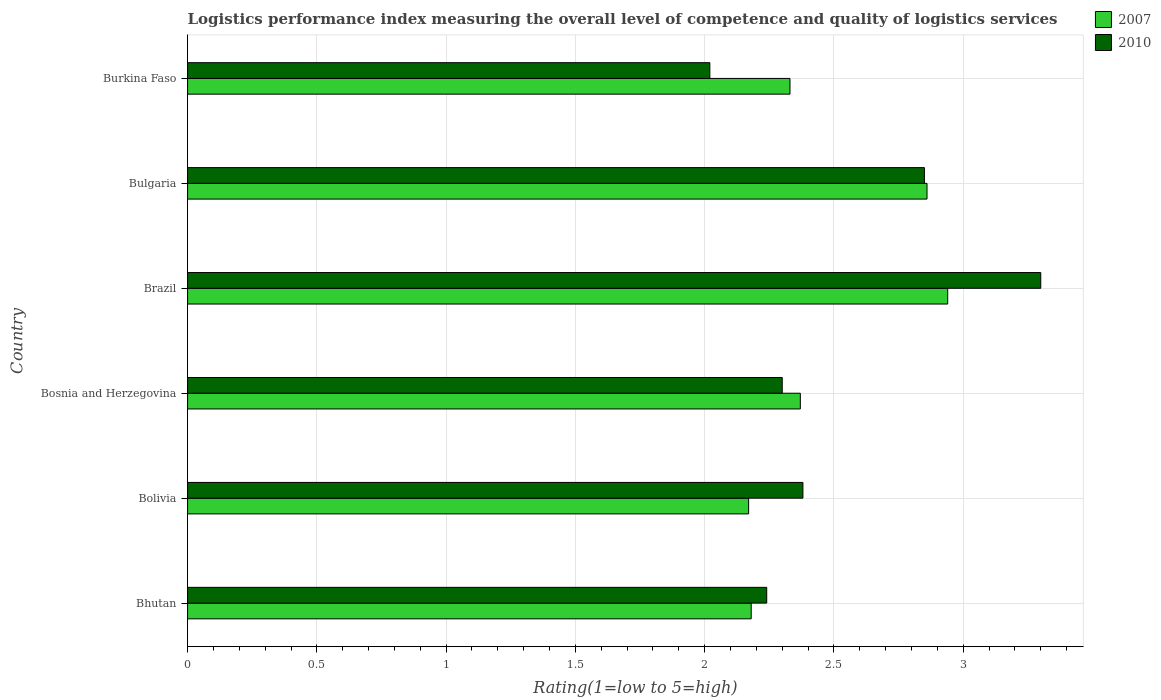How many different coloured bars are there?
Offer a very short reply. 2. Are the number of bars per tick equal to the number of legend labels?
Ensure brevity in your answer.  Yes. Are the number of bars on each tick of the Y-axis equal?
Provide a short and direct response. Yes. What is the Logistic performance index in 2010 in Bhutan?
Keep it short and to the point. 2.24. Across all countries, what is the maximum Logistic performance index in 2010?
Your answer should be very brief. 3.3. Across all countries, what is the minimum Logistic performance index in 2010?
Your answer should be compact. 2.02. In which country was the Logistic performance index in 2010 maximum?
Give a very brief answer. Brazil. In which country was the Logistic performance index in 2007 minimum?
Offer a terse response. Bolivia. What is the total Logistic performance index in 2007 in the graph?
Offer a very short reply. 14.85. What is the difference between the Logistic performance index in 2007 in Bulgaria and that in Burkina Faso?
Offer a terse response. 0.53. What is the difference between the Logistic performance index in 2007 in Bolivia and the Logistic performance index in 2010 in Bosnia and Herzegovina?
Give a very brief answer. -0.13. What is the average Logistic performance index in 2007 per country?
Your response must be concise. 2.48. What is the difference between the Logistic performance index in 2010 and Logistic performance index in 2007 in Bolivia?
Your response must be concise. 0.21. In how many countries, is the Logistic performance index in 2007 greater than 0.6 ?
Make the answer very short. 6. What is the ratio of the Logistic performance index in 2010 in Brazil to that in Bulgaria?
Offer a very short reply. 1.16. What is the difference between the highest and the second highest Logistic performance index in 2007?
Your answer should be compact. 0.08. What is the difference between the highest and the lowest Logistic performance index in 2010?
Provide a short and direct response. 1.28. What does the 2nd bar from the top in Bolivia represents?
Your response must be concise. 2007. How many bars are there?
Your response must be concise. 12. Are all the bars in the graph horizontal?
Keep it short and to the point. Yes. What is the difference between two consecutive major ticks on the X-axis?
Your answer should be very brief. 0.5. What is the title of the graph?
Your answer should be very brief. Logistics performance index measuring the overall level of competence and quality of logistics services. Does "2002" appear as one of the legend labels in the graph?
Provide a succinct answer. No. What is the label or title of the X-axis?
Give a very brief answer. Rating(1=low to 5=high). What is the Rating(1=low to 5=high) in 2007 in Bhutan?
Your answer should be compact. 2.18. What is the Rating(1=low to 5=high) in 2010 in Bhutan?
Offer a very short reply. 2.24. What is the Rating(1=low to 5=high) in 2007 in Bolivia?
Offer a terse response. 2.17. What is the Rating(1=low to 5=high) in 2010 in Bolivia?
Provide a short and direct response. 2.38. What is the Rating(1=low to 5=high) in 2007 in Bosnia and Herzegovina?
Your response must be concise. 2.37. What is the Rating(1=low to 5=high) in 2010 in Bosnia and Herzegovina?
Your answer should be very brief. 2.3. What is the Rating(1=low to 5=high) in 2007 in Brazil?
Give a very brief answer. 2.94. What is the Rating(1=low to 5=high) of 2007 in Bulgaria?
Your answer should be very brief. 2.86. What is the Rating(1=low to 5=high) in 2010 in Bulgaria?
Your answer should be very brief. 2.85. What is the Rating(1=low to 5=high) in 2007 in Burkina Faso?
Make the answer very short. 2.33. What is the Rating(1=low to 5=high) of 2010 in Burkina Faso?
Offer a terse response. 2.02. Across all countries, what is the maximum Rating(1=low to 5=high) of 2007?
Provide a succinct answer. 2.94. Across all countries, what is the maximum Rating(1=low to 5=high) in 2010?
Offer a very short reply. 3.3. Across all countries, what is the minimum Rating(1=low to 5=high) of 2007?
Provide a succinct answer. 2.17. Across all countries, what is the minimum Rating(1=low to 5=high) of 2010?
Offer a very short reply. 2.02. What is the total Rating(1=low to 5=high) of 2007 in the graph?
Keep it short and to the point. 14.85. What is the total Rating(1=low to 5=high) of 2010 in the graph?
Make the answer very short. 15.09. What is the difference between the Rating(1=low to 5=high) in 2010 in Bhutan and that in Bolivia?
Your answer should be very brief. -0.14. What is the difference between the Rating(1=low to 5=high) of 2007 in Bhutan and that in Bosnia and Herzegovina?
Provide a short and direct response. -0.19. What is the difference between the Rating(1=low to 5=high) of 2010 in Bhutan and that in Bosnia and Herzegovina?
Provide a short and direct response. -0.06. What is the difference between the Rating(1=low to 5=high) in 2007 in Bhutan and that in Brazil?
Provide a succinct answer. -0.76. What is the difference between the Rating(1=low to 5=high) of 2010 in Bhutan and that in Brazil?
Your answer should be compact. -1.06. What is the difference between the Rating(1=low to 5=high) in 2007 in Bhutan and that in Bulgaria?
Your answer should be compact. -0.68. What is the difference between the Rating(1=low to 5=high) of 2010 in Bhutan and that in Bulgaria?
Give a very brief answer. -0.61. What is the difference between the Rating(1=low to 5=high) of 2010 in Bhutan and that in Burkina Faso?
Provide a short and direct response. 0.22. What is the difference between the Rating(1=low to 5=high) in 2010 in Bolivia and that in Bosnia and Herzegovina?
Provide a succinct answer. 0.08. What is the difference between the Rating(1=low to 5=high) in 2007 in Bolivia and that in Brazil?
Keep it short and to the point. -0.77. What is the difference between the Rating(1=low to 5=high) in 2010 in Bolivia and that in Brazil?
Provide a succinct answer. -0.92. What is the difference between the Rating(1=low to 5=high) in 2007 in Bolivia and that in Bulgaria?
Provide a short and direct response. -0.69. What is the difference between the Rating(1=low to 5=high) of 2010 in Bolivia and that in Bulgaria?
Give a very brief answer. -0.47. What is the difference between the Rating(1=low to 5=high) of 2007 in Bolivia and that in Burkina Faso?
Make the answer very short. -0.16. What is the difference between the Rating(1=low to 5=high) in 2010 in Bolivia and that in Burkina Faso?
Your answer should be compact. 0.36. What is the difference between the Rating(1=low to 5=high) in 2007 in Bosnia and Herzegovina and that in Brazil?
Your answer should be compact. -0.57. What is the difference between the Rating(1=low to 5=high) in 2007 in Bosnia and Herzegovina and that in Bulgaria?
Make the answer very short. -0.49. What is the difference between the Rating(1=low to 5=high) of 2010 in Bosnia and Herzegovina and that in Bulgaria?
Ensure brevity in your answer.  -0.55. What is the difference between the Rating(1=low to 5=high) of 2010 in Bosnia and Herzegovina and that in Burkina Faso?
Make the answer very short. 0.28. What is the difference between the Rating(1=low to 5=high) of 2010 in Brazil and that in Bulgaria?
Offer a very short reply. 0.45. What is the difference between the Rating(1=low to 5=high) in 2007 in Brazil and that in Burkina Faso?
Keep it short and to the point. 0.61. What is the difference between the Rating(1=low to 5=high) in 2010 in Brazil and that in Burkina Faso?
Your response must be concise. 1.28. What is the difference between the Rating(1=low to 5=high) of 2007 in Bulgaria and that in Burkina Faso?
Provide a succinct answer. 0.53. What is the difference between the Rating(1=low to 5=high) of 2010 in Bulgaria and that in Burkina Faso?
Give a very brief answer. 0.83. What is the difference between the Rating(1=low to 5=high) of 2007 in Bhutan and the Rating(1=low to 5=high) of 2010 in Bosnia and Herzegovina?
Give a very brief answer. -0.12. What is the difference between the Rating(1=low to 5=high) of 2007 in Bhutan and the Rating(1=low to 5=high) of 2010 in Brazil?
Keep it short and to the point. -1.12. What is the difference between the Rating(1=low to 5=high) in 2007 in Bhutan and the Rating(1=low to 5=high) in 2010 in Bulgaria?
Make the answer very short. -0.67. What is the difference between the Rating(1=low to 5=high) of 2007 in Bhutan and the Rating(1=low to 5=high) of 2010 in Burkina Faso?
Keep it short and to the point. 0.16. What is the difference between the Rating(1=low to 5=high) in 2007 in Bolivia and the Rating(1=low to 5=high) in 2010 in Bosnia and Herzegovina?
Offer a terse response. -0.13. What is the difference between the Rating(1=low to 5=high) in 2007 in Bolivia and the Rating(1=low to 5=high) in 2010 in Brazil?
Your answer should be compact. -1.13. What is the difference between the Rating(1=low to 5=high) of 2007 in Bolivia and the Rating(1=low to 5=high) of 2010 in Bulgaria?
Provide a succinct answer. -0.68. What is the difference between the Rating(1=low to 5=high) in 2007 in Bolivia and the Rating(1=low to 5=high) in 2010 in Burkina Faso?
Your answer should be compact. 0.15. What is the difference between the Rating(1=low to 5=high) of 2007 in Bosnia and Herzegovina and the Rating(1=low to 5=high) of 2010 in Brazil?
Give a very brief answer. -0.93. What is the difference between the Rating(1=low to 5=high) in 2007 in Bosnia and Herzegovina and the Rating(1=low to 5=high) in 2010 in Bulgaria?
Ensure brevity in your answer.  -0.48. What is the difference between the Rating(1=low to 5=high) of 2007 in Bosnia and Herzegovina and the Rating(1=low to 5=high) of 2010 in Burkina Faso?
Provide a short and direct response. 0.35. What is the difference between the Rating(1=low to 5=high) of 2007 in Brazil and the Rating(1=low to 5=high) of 2010 in Bulgaria?
Ensure brevity in your answer.  0.09. What is the difference between the Rating(1=low to 5=high) of 2007 in Bulgaria and the Rating(1=low to 5=high) of 2010 in Burkina Faso?
Offer a very short reply. 0.84. What is the average Rating(1=low to 5=high) of 2007 per country?
Your response must be concise. 2.48. What is the average Rating(1=low to 5=high) of 2010 per country?
Offer a terse response. 2.52. What is the difference between the Rating(1=low to 5=high) of 2007 and Rating(1=low to 5=high) of 2010 in Bhutan?
Offer a very short reply. -0.06. What is the difference between the Rating(1=low to 5=high) of 2007 and Rating(1=low to 5=high) of 2010 in Bolivia?
Your answer should be very brief. -0.21. What is the difference between the Rating(1=low to 5=high) of 2007 and Rating(1=low to 5=high) of 2010 in Bosnia and Herzegovina?
Ensure brevity in your answer.  0.07. What is the difference between the Rating(1=low to 5=high) in 2007 and Rating(1=low to 5=high) in 2010 in Brazil?
Provide a succinct answer. -0.36. What is the difference between the Rating(1=low to 5=high) of 2007 and Rating(1=low to 5=high) of 2010 in Bulgaria?
Your answer should be compact. 0.01. What is the difference between the Rating(1=low to 5=high) in 2007 and Rating(1=low to 5=high) in 2010 in Burkina Faso?
Offer a terse response. 0.31. What is the ratio of the Rating(1=low to 5=high) of 2010 in Bhutan to that in Bolivia?
Make the answer very short. 0.94. What is the ratio of the Rating(1=low to 5=high) in 2007 in Bhutan to that in Bosnia and Herzegovina?
Keep it short and to the point. 0.92. What is the ratio of the Rating(1=low to 5=high) of 2010 in Bhutan to that in Bosnia and Herzegovina?
Keep it short and to the point. 0.97. What is the ratio of the Rating(1=low to 5=high) of 2007 in Bhutan to that in Brazil?
Give a very brief answer. 0.74. What is the ratio of the Rating(1=low to 5=high) in 2010 in Bhutan to that in Brazil?
Provide a succinct answer. 0.68. What is the ratio of the Rating(1=low to 5=high) in 2007 in Bhutan to that in Bulgaria?
Your response must be concise. 0.76. What is the ratio of the Rating(1=low to 5=high) in 2010 in Bhutan to that in Bulgaria?
Provide a succinct answer. 0.79. What is the ratio of the Rating(1=low to 5=high) in 2007 in Bhutan to that in Burkina Faso?
Keep it short and to the point. 0.94. What is the ratio of the Rating(1=low to 5=high) of 2010 in Bhutan to that in Burkina Faso?
Your answer should be very brief. 1.11. What is the ratio of the Rating(1=low to 5=high) of 2007 in Bolivia to that in Bosnia and Herzegovina?
Give a very brief answer. 0.92. What is the ratio of the Rating(1=low to 5=high) in 2010 in Bolivia to that in Bosnia and Herzegovina?
Offer a terse response. 1.03. What is the ratio of the Rating(1=low to 5=high) in 2007 in Bolivia to that in Brazil?
Provide a short and direct response. 0.74. What is the ratio of the Rating(1=low to 5=high) of 2010 in Bolivia to that in Brazil?
Offer a terse response. 0.72. What is the ratio of the Rating(1=low to 5=high) in 2007 in Bolivia to that in Bulgaria?
Keep it short and to the point. 0.76. What is the ratio of the Rating(1=low to 5=high) in 2010 in Bolivia to that in Bulgaria?
Give a very brief answer. 0.84. What is the ratio of the Rating(1=low to 5=high) in 2007 in Bolivia to that in Burkina Faso?
Provide a short and direct response. 0.93. What is the ratio of the Rating(1=low to 5=high) in 2010 in Bolivia to that in Burkina Faso?
Your answer should be very brief. 1.18. What is the ratio of the Rating(1=low to 5=high) in 2007 in Bosnia and Herzegovina to that in Brazil?
Your response must be concise. 0.81. What is the ratio of the Rating(1=low to 5=high) in 2010 in Bosnia and Herzegovina to that in Brazil?
Provide a succinct answer. 0.7. What is the ratio of the Rating(1=low to 5=high) in 2007 in Bosnia and Herzegovina to that in Bulgaria?
Offer a very short reply. 0.83. What is the ratio of the Rating(1=low to 5=high) in 2010 in Bosnia and Herzegovina to that in Bulgaria?
Provide a succinct answer. 0.81. What is the ratio of the Rating(1=low to 5=high) in 2007 in Bosnia and Herzegovina to that in Burkina Faso?
Your response must be concise. 1.02. What is the ratio of the Rating(1=low to 5=high) of 2010 in Bosnia and Herzegovina to that in Burkina Faso?
Make the answer very short. 1.14. What is the ratio of the Rating(1=low to 5=high) in 2007 in Brazil to that in Bulgaria?
Your answer should be very brief. 1.03. What is the ratio of the Rating(1=low to 5=high) of 2010 in Brazil to that in Bulgaria?
Make the answer very short. 1.16. What is the ratio of the Rating(1=low to 5=high) in 2007 in Brazil to that in Burkina Faso?
Your answer should be compact. 1.26. What is the ratio of the Rating(1=low to 5=high) of 2010 in Brazil to that in Burkina Faso?
Your answer should be compact. 1.63. What is the ratio of the Rating(1=low to 5=high) of 2007 in Bulgaria to that in Burkina Faso?
Your answer should be compact. 1.23. What is the ratio of the Rating(1=low to 5=high) of 2010 in Bulgaria to that in Burkina Faso?
Provide a succinct answer. 1.41. What is the difference between the highest and the second highest Rating(1=low to 5=high) of 2010?
Your answer should be compact. 0.45. What is the difference between the highest and the lowest Rating(1=low to 5=high) in 2007?
Make the answer very short. 0.77. What is the difference between the highest and the lowest Rating(1=low to 5=high) of 2010?
Keep it short and to the point. 1.28. 